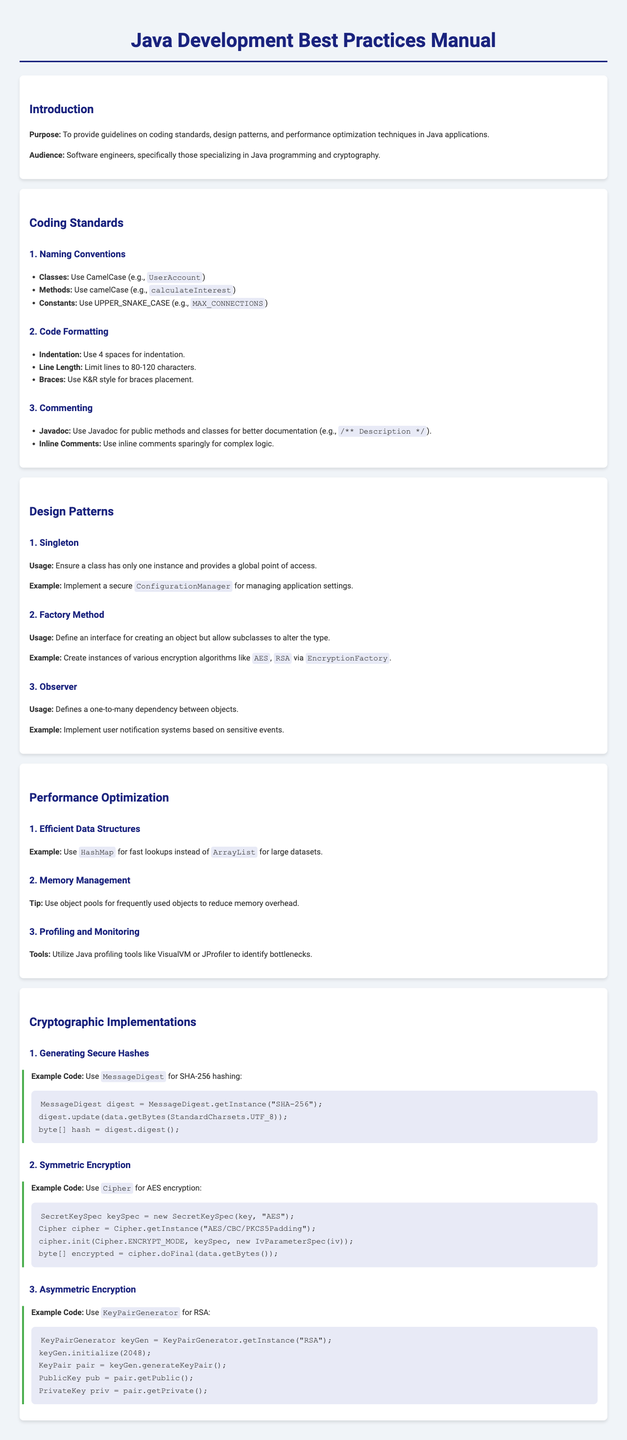What is the purpose of the manual? The purpose of the manual is to provide guidelines on coding standards, design patterns, and performance optimization techniques in Java applications.
Answer: To provide guidelines on coding standards, design patterns, and performance optimization techniques in Java applications What format should method names follow? The document specifies naming conventions for methods to be in camelCase.
Answer: camelCase What is the example of generating secure hashes? The document provides an example code using the MessageDigest class for SHA-256 hashing.
Answer: MessageDigest What design pattern ensures a class has only one instance? The design pattern described that ensures a class has only one instance is the Singleton pattern.
Answer: Singleton What data structure is recommended for fast lookups? The manual recommends using HashMap for fast lookups instead of ArrayList.
Answer: HashMap Which encryption method uses a key size of 2048? The asymmetric encryption method that uses a key size of 2048 is RSA.
Answer: RSA What is the maximum number of characters for line length? The document advises limiting lines to a maximum of 120 characters.
Answer: 120 What specification is recommended for class naming conventions? The document specifies CamelCase for class naming conventions.
Answer: CamelCase What tool can be used for profiling in Java? A tool mentioned for profiling and monitoring in Java is VisualVM.
Answer: VisualVM What is the initialization method for Cipher in AES encryption? The initialization method for Cipher in AES encryption is encrypt_mode.
Answer: ENCRYPT_MODE 